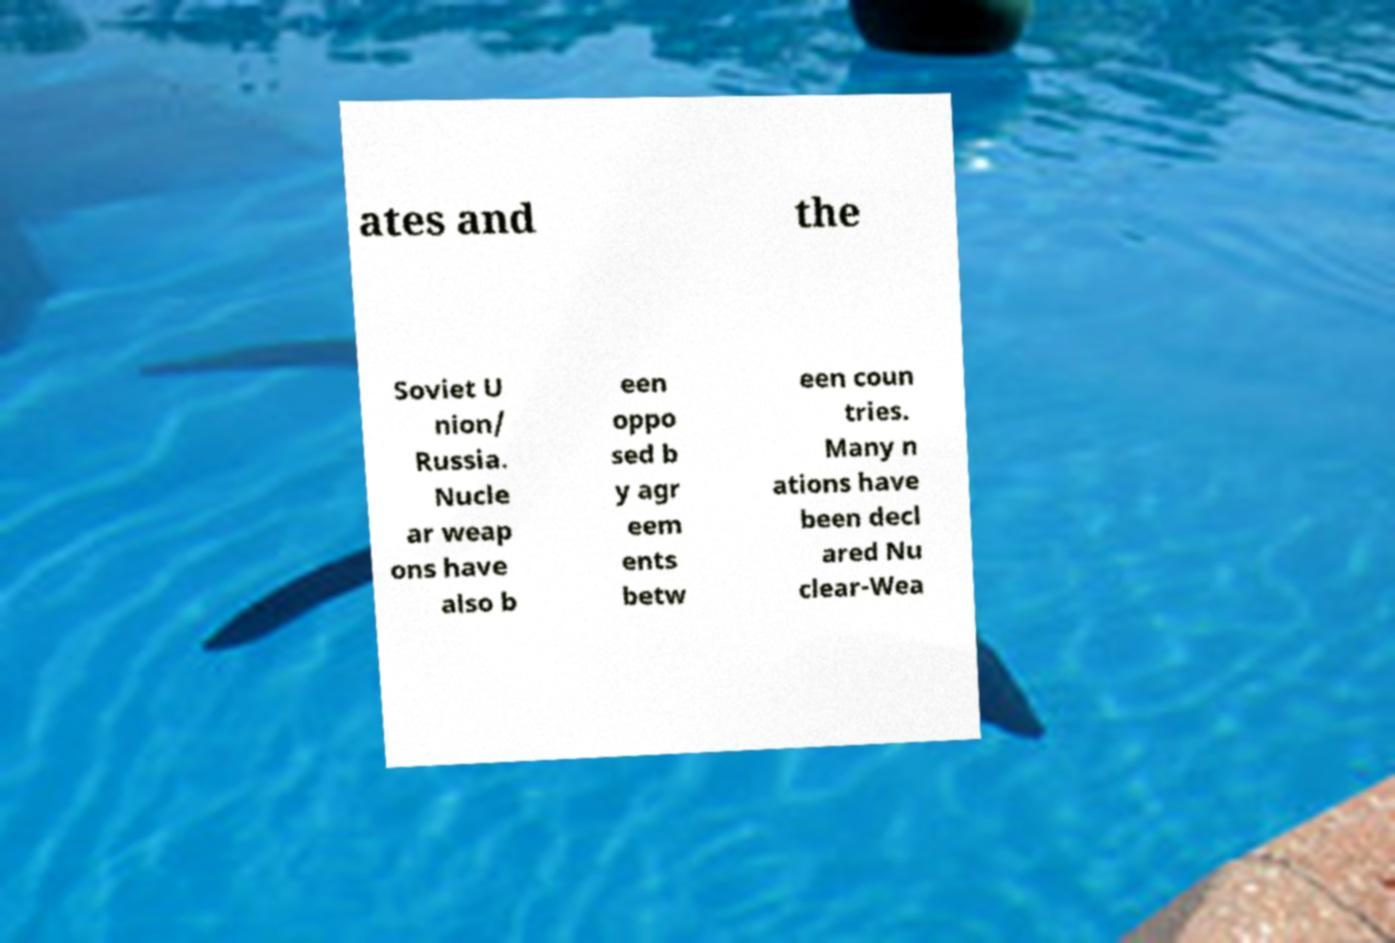There's text embedded in this image that I need extracted. Can you transcribe it verbatim? ates and the Soviet U nion/ Russia. Nucle ar weap ons have also b een oppo sed b y agr eem ents betw een coun tries. Many n ations have been decl ared Nu clear-Wea 